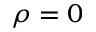<formula> <loc_0><loc_0><loc_500><loc_500>\rho = 0</formula> 